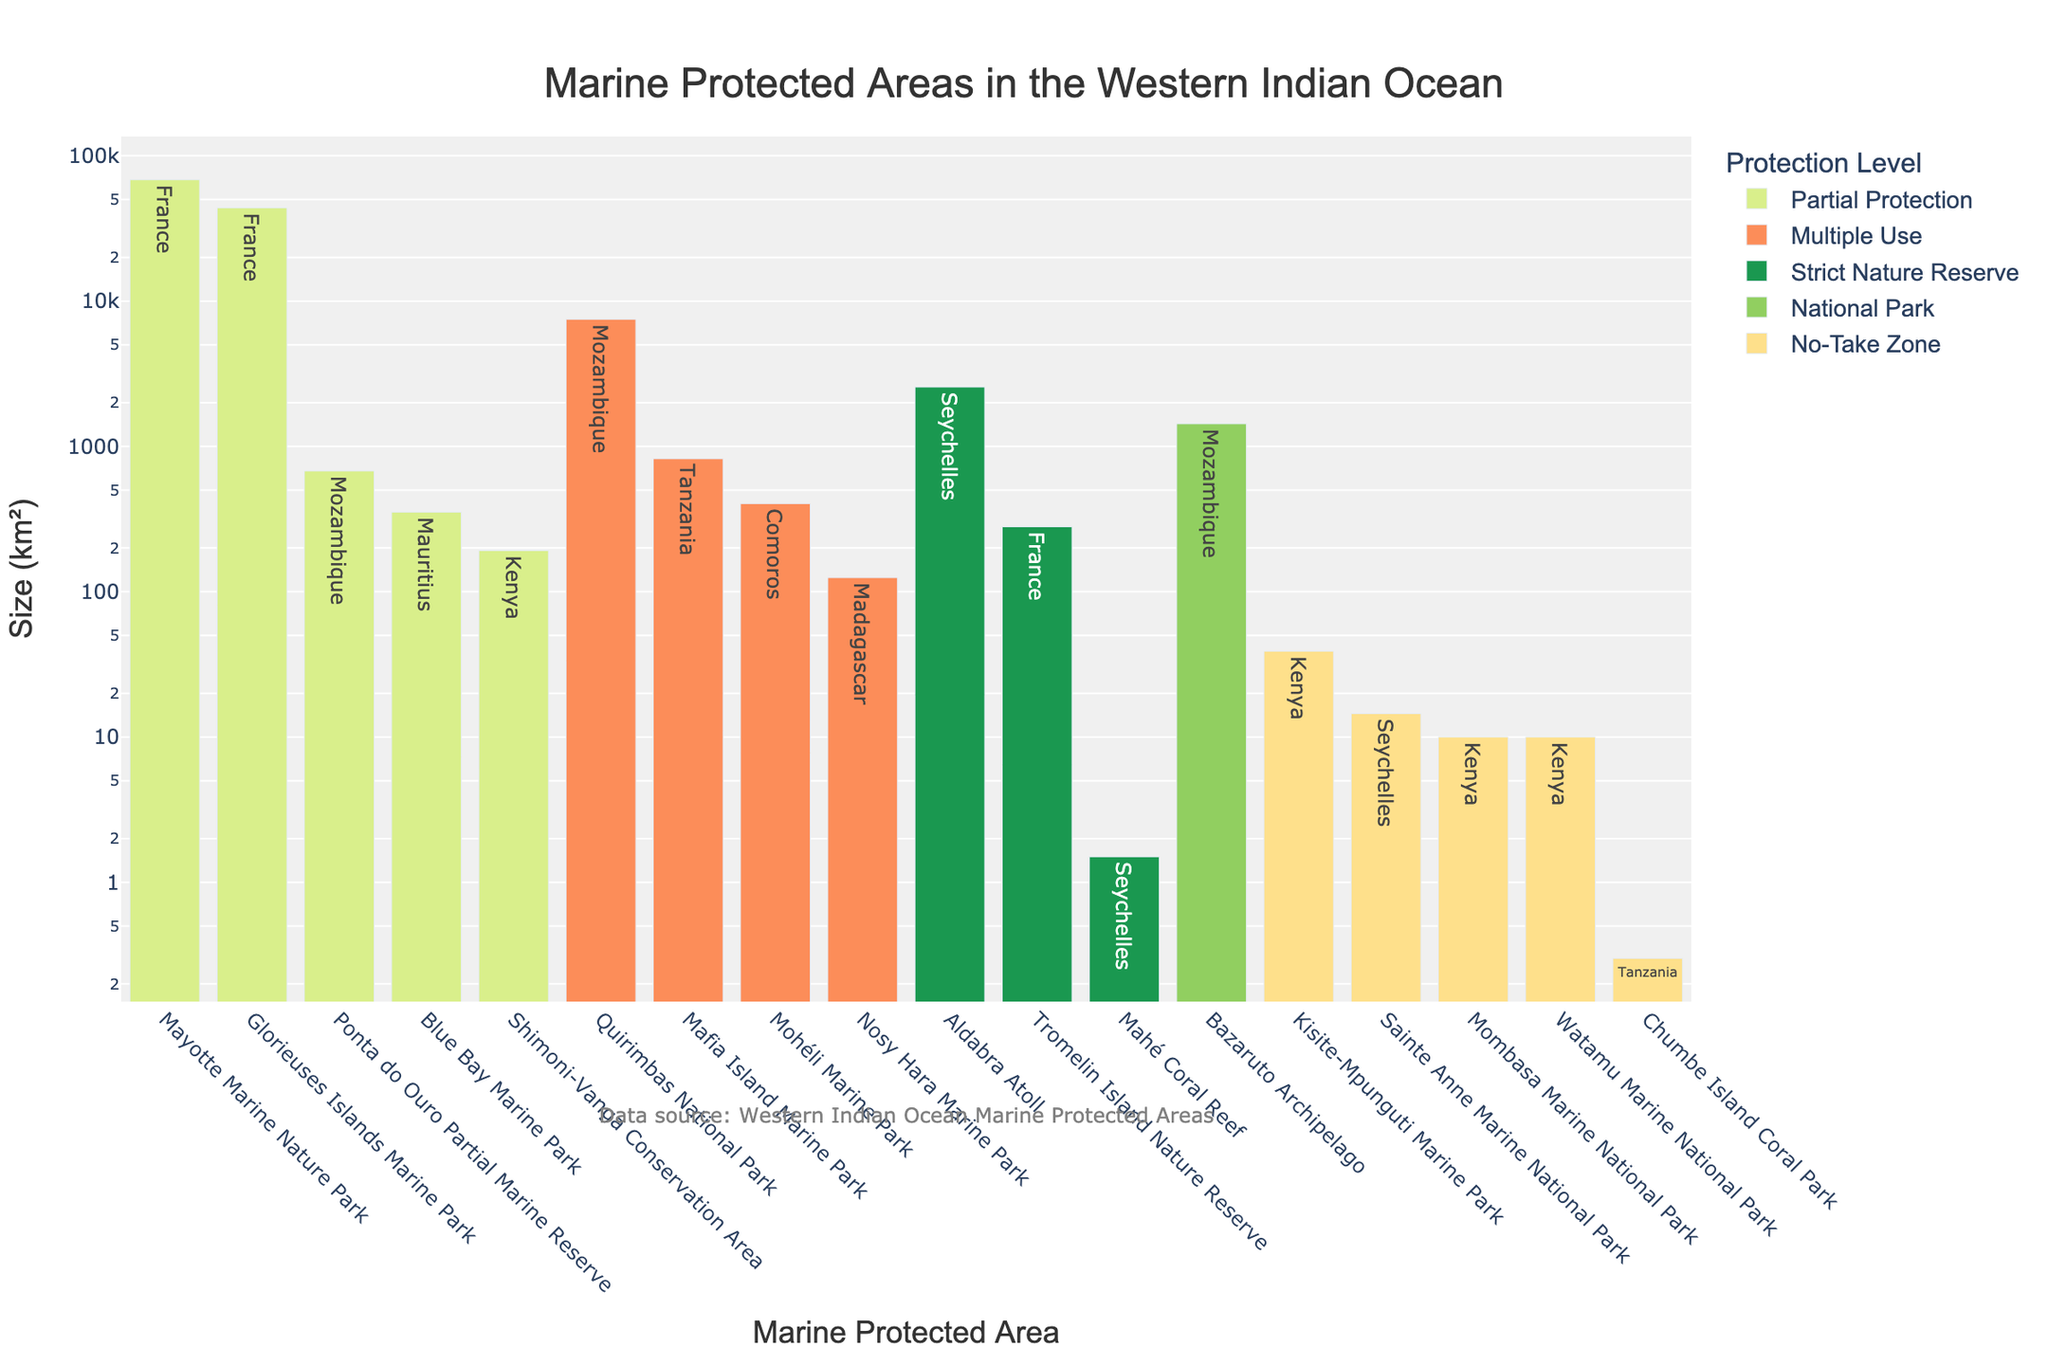Which marine protected area has the largest size? The bar chart shows the sizes of the marine protected areas in descending order. The tallest bar corresponds to Mayotte Marine Nature Park.
Answer: Mayotte Marine Nature Park What's the total size of strict nature reserves? In the chart, locate the bars colored for strict nature reserves and sum their sizes: Aldabra Atoll (2559 km²), Mahé Coral Reef (1.5 km²), Tromelin Island Nature Reserve (280 km²). Thus, the total size is 2559 + 1.5 + 280 = 2840.5 km².
Answer: 2840.5 km² Which country has the highest total size of marine protected areas shown in the chart? Look at the text labels for each bar, group them by country, and sum their sizes: France's parks add up (Glorieuses Islands 43800 km² + Mayotte 68381 km² + Tromelin 280 km²), totaling 112461 km², the highest.
Answer: France How does the size of the Blue Bay Marine Park compare to that of the Bazaruto Archipelago? Compare the heights of the respective bars: Blue Bay Marine Park (353 km²) and Bazaruto Archipelago (1430 km²). The Bazaruto Archipelago's size is larger than Blue Bay Marine Park's.
Answer: Bazaruto Archipelago is larger What is the average size of marine protected areas classified under 'Partial Protection'? Identify bars associated with 'Partial Protection' and sum their sizes: Blue Bay Marine Park (353 km²), Glorieuses Islands Marine Park (43800 km²), Mayotte Marine Nature Park (68381 km²), Ponta do Ouro Partial Marine Reserve (678 km²), Shimoni-Vanga Conservation Area (192 km²). Sum these sizes: 353 + 43800 + 68381 + 678 + 192 = 113404 km². There are 5 parks, so the average size = 113404 / 5 = 22680.8 km².
Answer: 22680.8 km² Which marine protected area has the smallest size among those classified under 'No-Take Zone'? Identify bars colored for 'No-Take Zone' and locate the shortest bar among them, which is Chumbe Island Coral Park with a size of 0.3 km².
Answer: Chumbe Island Coral Park What's the combined size of marine protected areas in Kenya? Sum the sizes of the bars labeled with text 'Kenya': Kisite-Mpunguti Marine Park (39 km²), Mombasa Marine National Park (10 km²), Watamu Marine National Park (10 km²). Thus, the total size is 39 + 10 + 10 = 59 km².
Answer: 59 km² How many marine protected areas have sizes larger than 5000 km²? Count the number of bars with sizes larger than 5000 km²: Mayotte Marine Nature Park (68381 km²), Glorieuses Islands Marine Park (43800 km²), and Quirimbas National Park (7500 km²). There are 3 such areas.
Answer: 3 